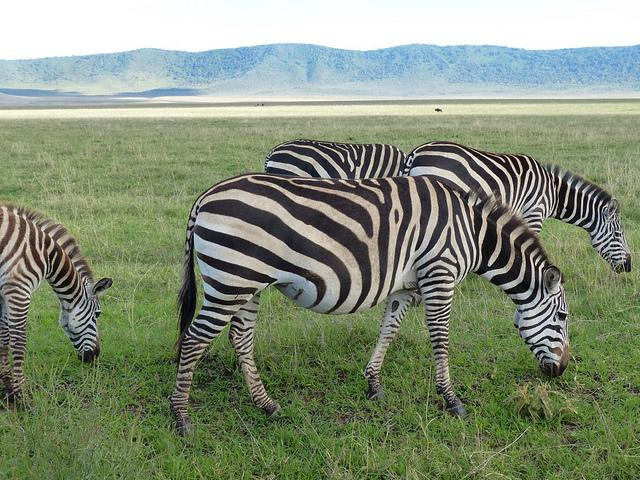What are the zebras doing? grazing 